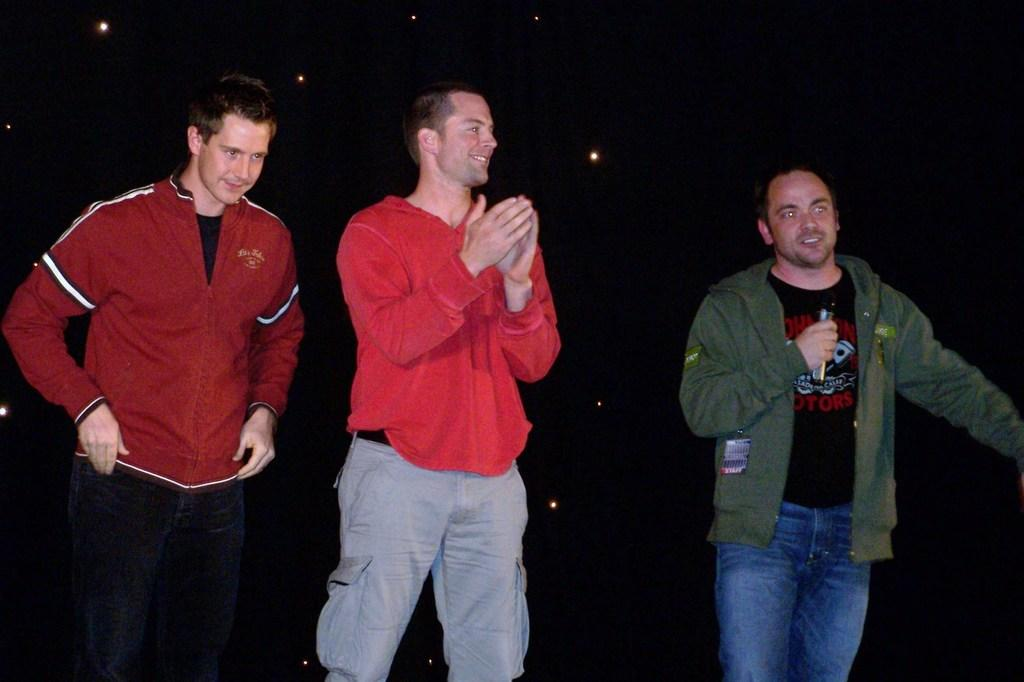How many people are in the image? There are three men in the image. What is one of the men holding in his hand? One of the men is holding a microphone in his hand. Can you describe the background of the image? The background of the image is dark. What type of van can be seen in the image? There is no van present in the image. How much profit did the men make from their performance in the image? There is no information about profit in the image. 